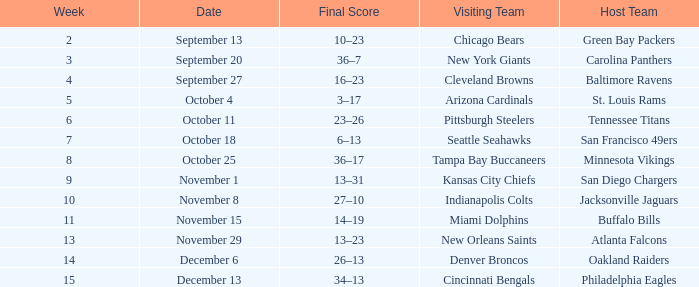What team played on the road against the Buffalo Bills at home ? Miami Dolphins. Could you parse the entire table as a dict? {'header': ['Week', 'Date', 'Final Score', 'Visiting Team', 'Host Team'], 'rows': [['2', 'September 13', '10–23', 'Chicago Bears', 'Green Bay Packers'], ['3', 'September 20', '36–7', 'New York Giants', 'Carolina Panthers'], ['4', 'September 27', '16–23', 'Cleveland Browns', 'Baltimore Ravens'], ['5', 'October 4', '3–17', 'Arizona Cardinals', 'St. Louis Rams'], ['6', 'October 11', '23–26', 'Pittsburgh Steelers', 'Tennessee Titans'], ['7', 'October 18', '6–13', 'Seattle Seahawks', 'San Francisco 49ers'], ['8', 'October 25', '36–17', 'Tampa Bay Buccaneers', 'Minnesota Vikings'], ['9', 'November 1', '13–31', 'Kansas City Chiefs', 'San Diego Chargers'], ['10', 'November 8', '27–10', 'Indianapolis Colts', 'Jacksonville Jaguars'], ['11', 'November 15', '14–19', 'Miami Dolphins', 'Buffalo Bills'], ['13', 'November 29', '13–23', 'New Orleans Saints', 'Atlanta Falcons'], ['14', 'December 6', '26–13', 'Denver Broncos', 'Oakland Raiders'], ['15', 'December 13', '34–13', 'Cincinnati Bengals', 'Philadelphia Eagles']]} 